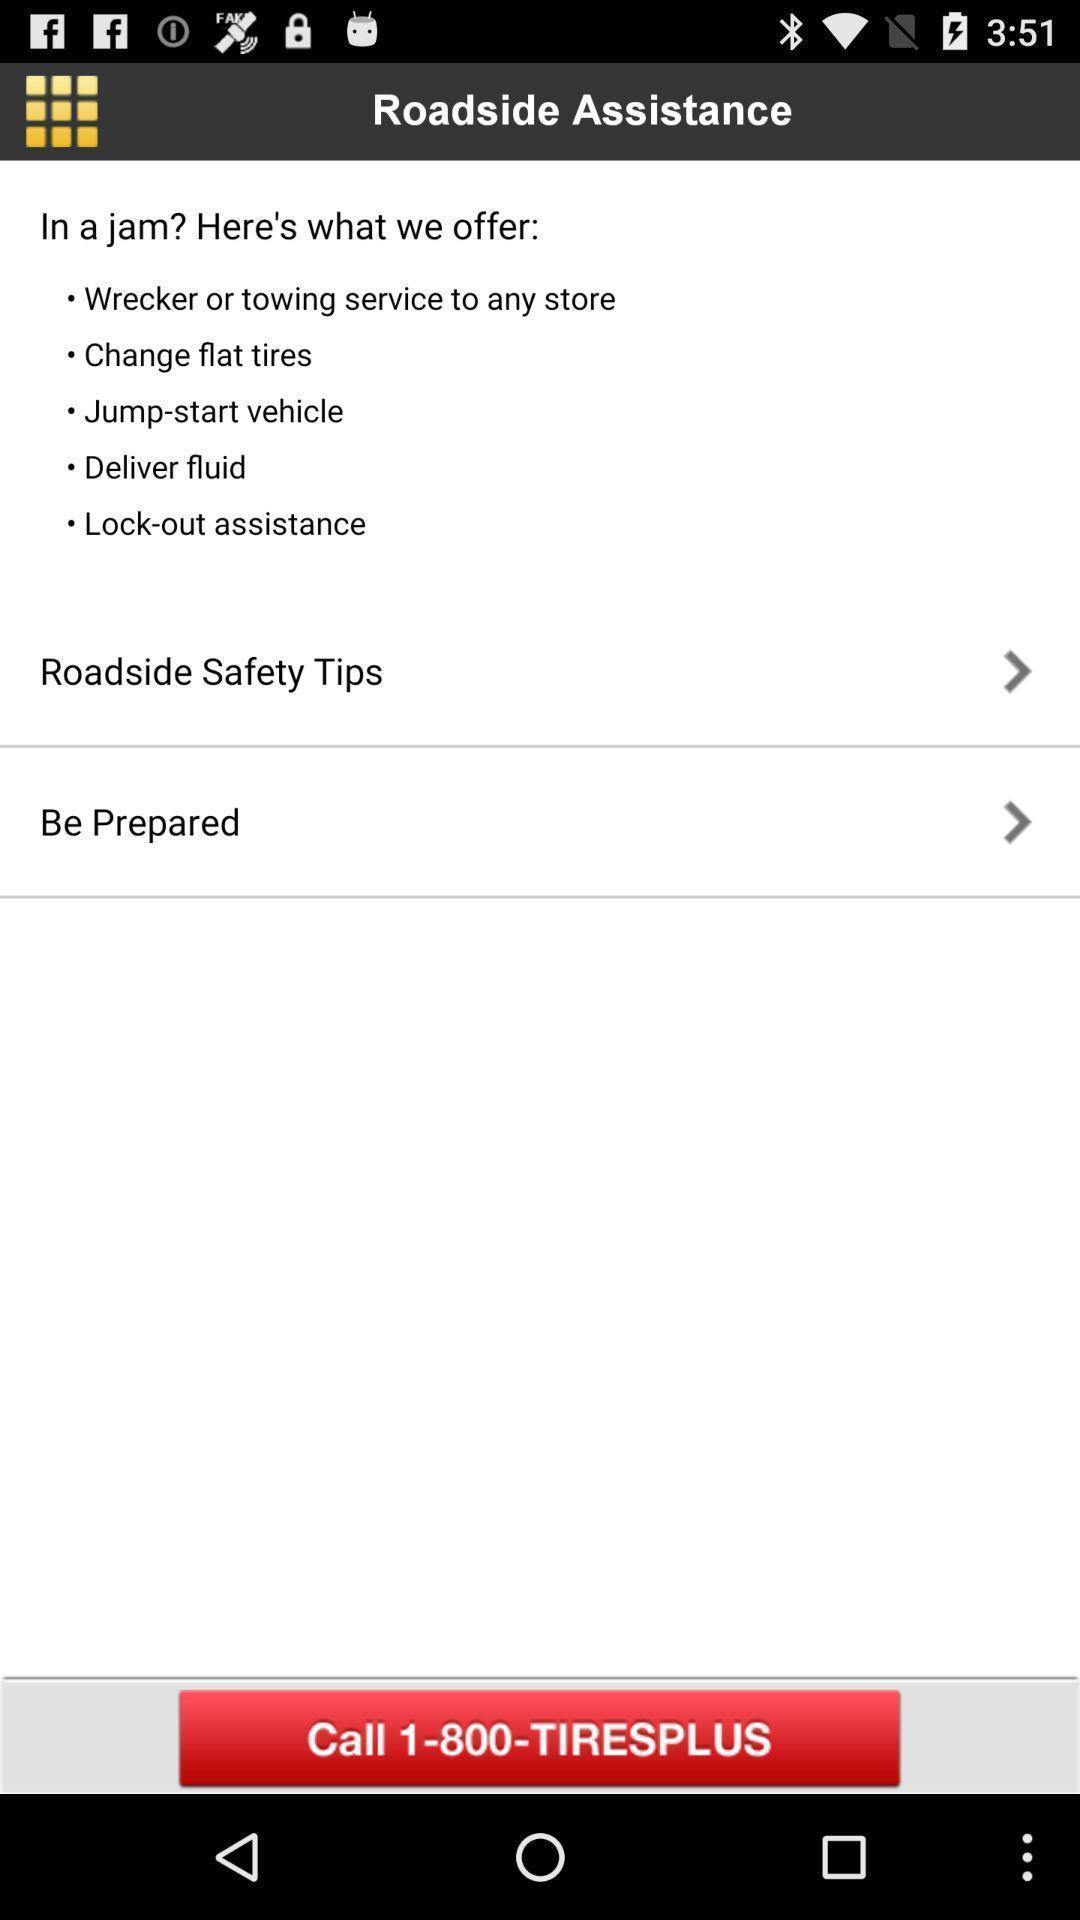What details can you identify in this image? Page showing roadside help options. 